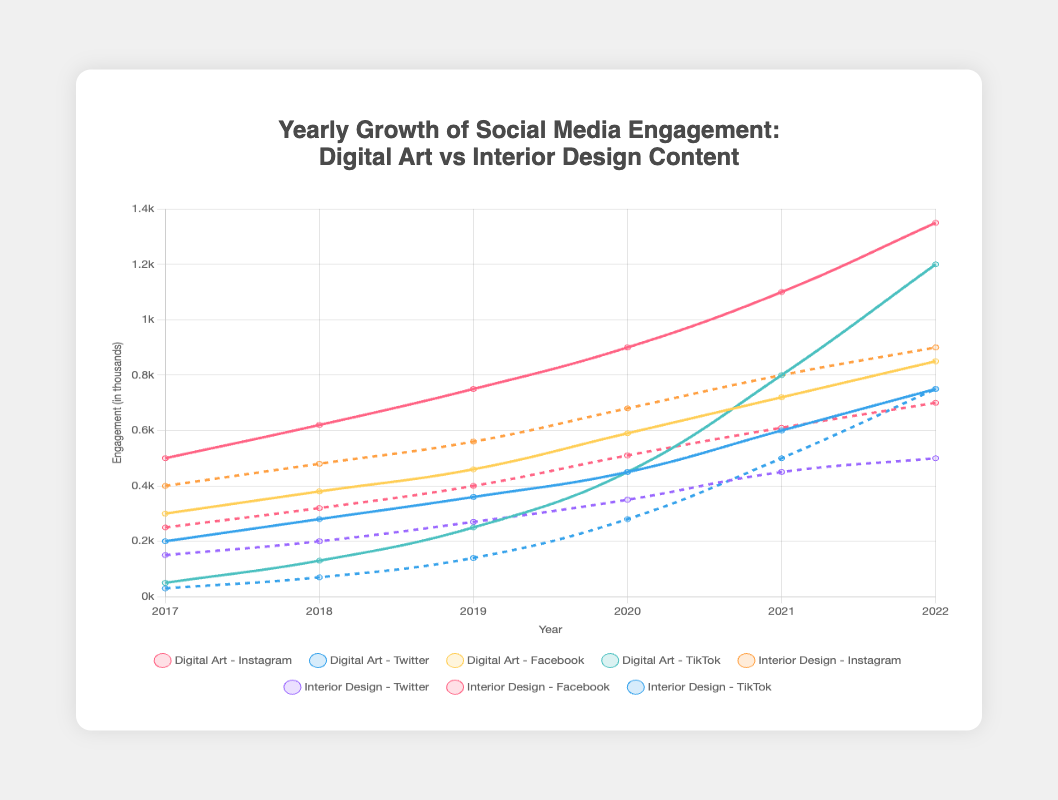What is the total engagement for Digital Art on Instagram in 2021 and 2022? Add the engagement values for Digital Art on Instagram for the years 2021 and 2022: 1100 (2021) + 1350 (2022) = 2450
Answer: 2450 Which platform saw the highest engagement for Interior Design in 2022? The highest engagement for Interior Design in 2022 can be seen by comparing the values for all platforms: Instagram (900), Twitter (500), Facebook (700), TikTok (750). The highest value is 900 on Instagram
Answer: Instagram How much did the engagement for Digital Art on TikTok increase from 2018 to 2020? Calculate the difference in engagement for Digital Art on TikTok between 2018 (130) and 2020 (450): 450 - 130 = 320
Answer: 320 Which content type had higher engagement on Twitter in 2019, Digital Art or Interior Design? Compare the Twitter engagement values for Digital Art (360) and Interior Design (270) in 2019; 360 is greater than 270
Answer: Digital Art What was the average engagement for Interior Design on Facebook over the whole period (2017-2022)? Sum the engagement values for Interior Design on Facebook over the years: 250 + 320 + 400 + 510 + 610 + 700 = 2790, then divide by the number of years (6): 2790/6 = 465
Answer: 465 Which content type showed the steadiest growth on Instagram from 2017 to 2022? Compare the trends for Digital Art and Interior Design on Instagram. Digital Art shows a steady growth (500, 620, 750, 900, 1100, 1350), while Interior Design also increases steadily but at a slightly slower rate (400, 480, 560, 680, 800, 900). The growth for Digital Art is more pronounced and steady
Answer: Digital Art In which year did Interior Design see the largest increase in engagement on TikTok? Find the year-to-year differences for Interior Design on TikTok: from 2017 to 2018 (70-30=40), from 2018 to 2019 (140-70=70), from 2019 to 2020 (280-140=140), from 2020 to 2021 (500-280=220), and from 2021 to 2022 (750-500=250). The largest increase is from 2020 to 2021
Answer: 2021 What is the difference between the highest and lowest engagement for Digital Art on Facebook over the period 2017-2022? The highest engagement for Digital Art on Facebook is 850 (in 2022) and the lowest is 300 (in 2017). The difference is 850-300 = 550
Answer: 550 How did the engagement for Digital Art on Twitter compare to Interior Design on Twitter in 2020? Compare the engagement values for Digital Art (450) and Interior Design (350) on Twitter in 2020; 450 is higher than 350
Answer: Digital Art 